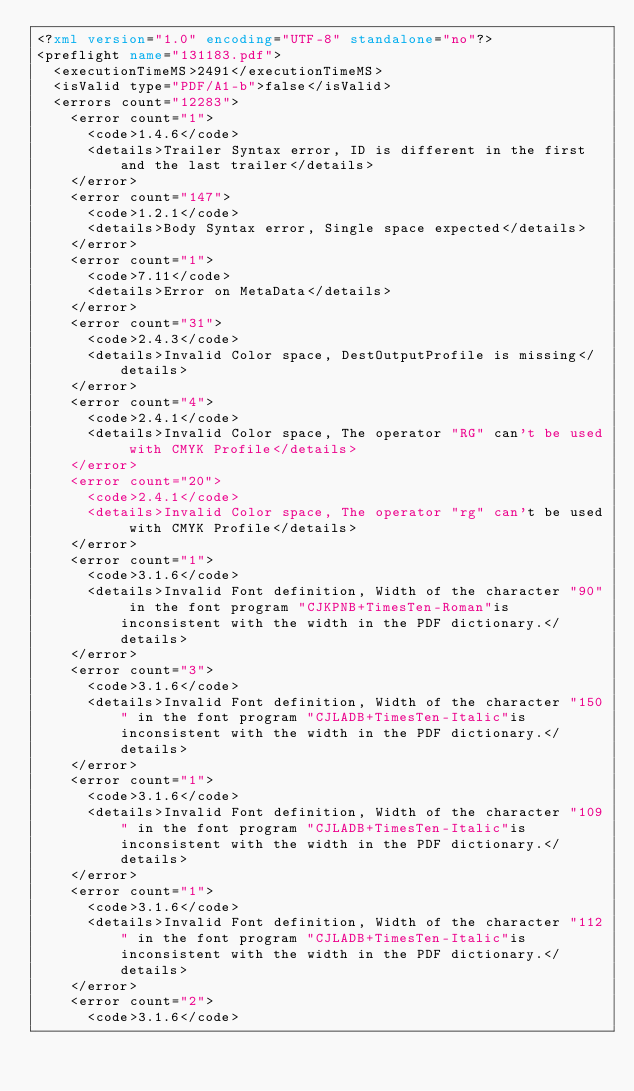Convert code to text. <code><loc_0><loc_0><loc_500><loc_500><_XML_><?xml version="1.0" encoding="UTF-8" standalone="no"?>
<preflight name="131183.pdf">
  <executionTimeMS>2491</executionTimeMS>
  <isValid type="PDF/A1-b">false</isValid>
  <errors count="12283">
    <error count="1">
      <code>1.4.6</code>
      <details>Trailer Syntax error, ID is different in the first and the last trailer</details>
    </error>
    <error count="147">
      <code>1.2.1</code>
      <details>Body Syntax error, Single space expected</details>
    </error>
    <error count="1">
      <code>7.11</code>
      <details>Error on MetaData</details>
    </error>
    <error count="31">
      <code>2.4.3</code>
      <details>Invalid Color space, DestOutputProfile is missing</details>
    </error>
    <error count="4">
      <code>2.4.1</code>
      <details>Invalid Color space, The operator "RG" can't be used with CMYK Profile</details>
    </error>
    <error count="20">
      <code>2.4.1</code>
      <details>Invalid Color space, The operator "rg" can't be used with CMYK Profile</details>
    </error>
    <error count="1">
      <code>3.1.6</code>
      <details>Invalid Font definition, Width of the character "90" in the font program "CJKPNB+TimesTen-Roman"is inconsistent with the width in the PDF dictionary.</details>
    </error>
    <error count="3">
      <code>3.1.6</code>
      <details>Invalid Font definition, Width of the character "150" in the font program "CJLADB+TimesTen-Italic"is inconsistent with the width in the PDF dictionary.</details>
    </error>
    <error count="1">
      <code>3.1.6</code>
      <details>Invalid Font definition, Width of the character "109" in the font program "CJLADB+TimesTen-Italic"is inconsistent with the width in the PDF dictionary.</details>
    </error>
    <error count="1">
      <code>3.1.6</code>
      <details>Invalid Font definition, Width of the character "112" in the font program "CJLADB+TimesTen-Italic"is inconsistent with the width in the PDF dictionary.</details>
    </error>
    <error count="2">
      <code>3.1.6</code></code> 